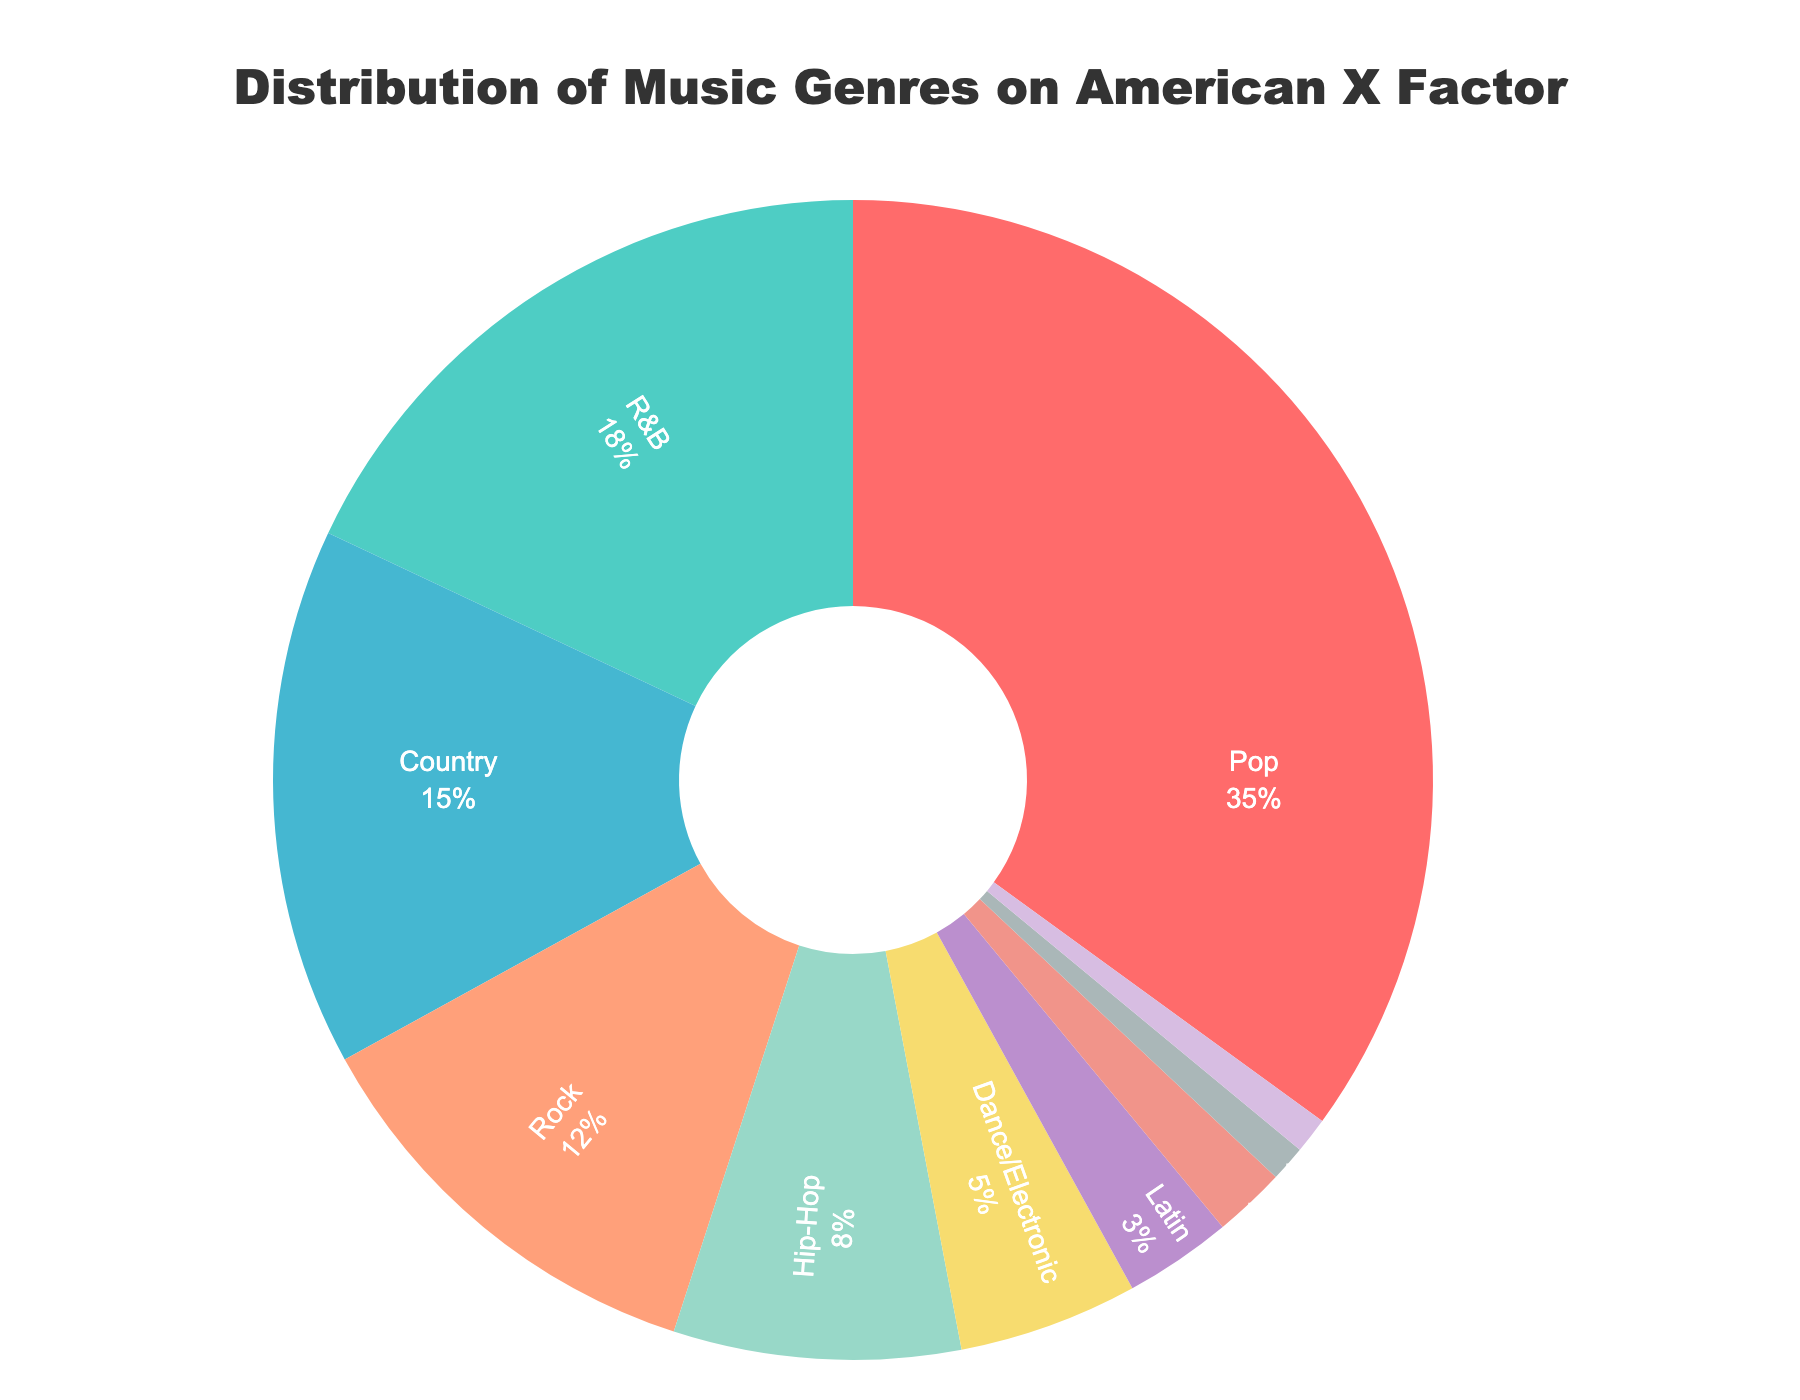What is the most popular music genre on American X Factor over the past 5 seasons? The pie chart shows the distribution of music genres on American X Factor and reveals that Pop has the largest section.
Answer: Pop What percentage of genres are represented by Pop and R&B combined? According to the pie chart, Pop represents 35% and R&B represents 18%. Adding these percentages gives us 35 + 18 = 53%.
Answer: 53% Which genres each have a smaller share than Country? Country occupies 15%, so any genre with a share less than this is smaller. These genres are Rock (12%), Hip-Hop (8%), Dance/Electronic (5%), Latin (3%), Folk/Americana (2%), Alternative (1%), and Musical Theater (1%).
Answer: Rock, Hip-Hop, Dance/Electronic, Latin, Folk/Americana, Alternative, Musical Theater What is the percentage difference between Rock and Dance/Electronic music? The pie chart shows Rock at 12% and Dance/Electronic at 5%. The difference is 12 - 5 = 7%.
Answer: 7% If you combine the percentages of Latin, Folk/Americana, Alternative, and Musical Theater, what total percentage do you get? The pie chart shows Latin at 3%, Folk/Americana at 2%, Alternative at 1%, and Musical Theater at 1%. Adding these percentages gives us 3 + 2 + 1 + 1 = 7%.
Answer: 7% Is Hip-Hop more or less popular than R&B on the show? According to the pie chart, Hip-Hop represents 8%, while R&B represents 18%, so Hip-Hop is less popular than R&B.
Answer: Less Which genre has a percentage closest to the average percentage of all the genres? The total percentage is 100%, and there are 10 genres. The average percentage is 100 / 10 = 10%. The genre closest to 10% is Rock (12%).
Answer: Rock How many genres have a representation of 5% or more? According to the pie chart, the genres that have 5% or more are Pop, R&B, Country, Rock, Hip-Hop, and Dance/Electronic. This gives us 6 genres.
Answer: 6 What visual cue indicates the Pop genre? The Pop genre is represented by the largest red section in the pie chart, sitting prominently at 35%.
Answer: Red section 